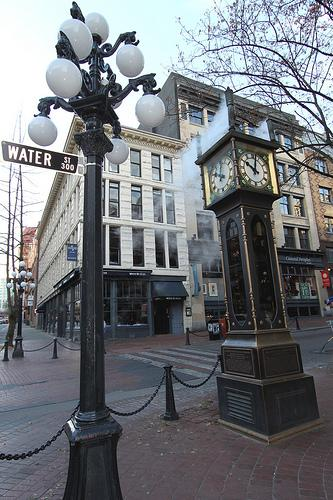Question: where was this picture taken?
Choices:
A. In a city.
B. Downtown.
C. Water St.
D. Near a store.
Answer with the letter. Answer: C Question: what time does the clock say?
Choices:
A. 9:45.
B. 8:30.
C. 10:03.
D. 7:00.
Answer with the letter. Answer: C Question: what type of ground is the clock sitting on?
Choices:
A. Lawn.
B. Sand.
C. Bricks.
D. Concrete.
Answer with the letter. Answer: C Question: what block of water street is pictured here?
Choices:
A. The right block.
B. The 300 block.
C. The left block.
D. The biggest block.
Answer with the letter. Answer: B 